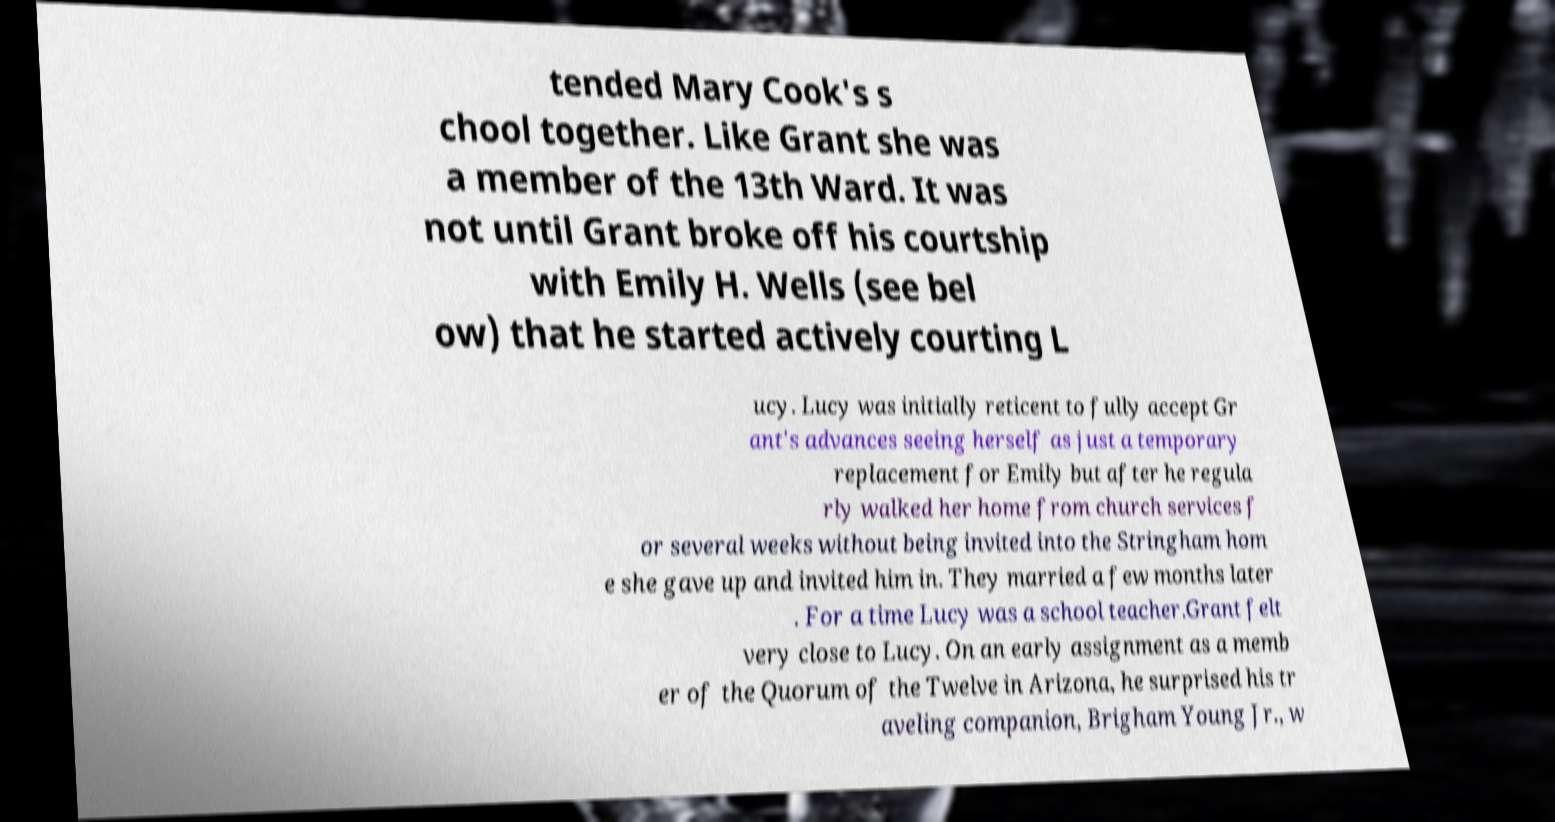Can you accurately transcribe the text from the provided image for me? tended Mary Cook's s chool together. Like Grant she was a member of the 13th Ward. It was not until Grant broke off his courtship with Emily H. Wells (see bel ow) that he started actively courting L ucy. Lucy was initially reticent to fully accept Gr ant's advances seeing herself as just a temporary replacement for Emily but after he regula rly walked her home from church services f or several weeks without being invited into the Stringham hom e she gave up and invited him in. They married a few months later . For a time Lucy was a school teacher.Grant felt very close to Lucy. On an early assignment as a memb er of the Quorum of the Twelve in Arizona, he surprised his tr aveling companion, Brigham Young Jr., w 